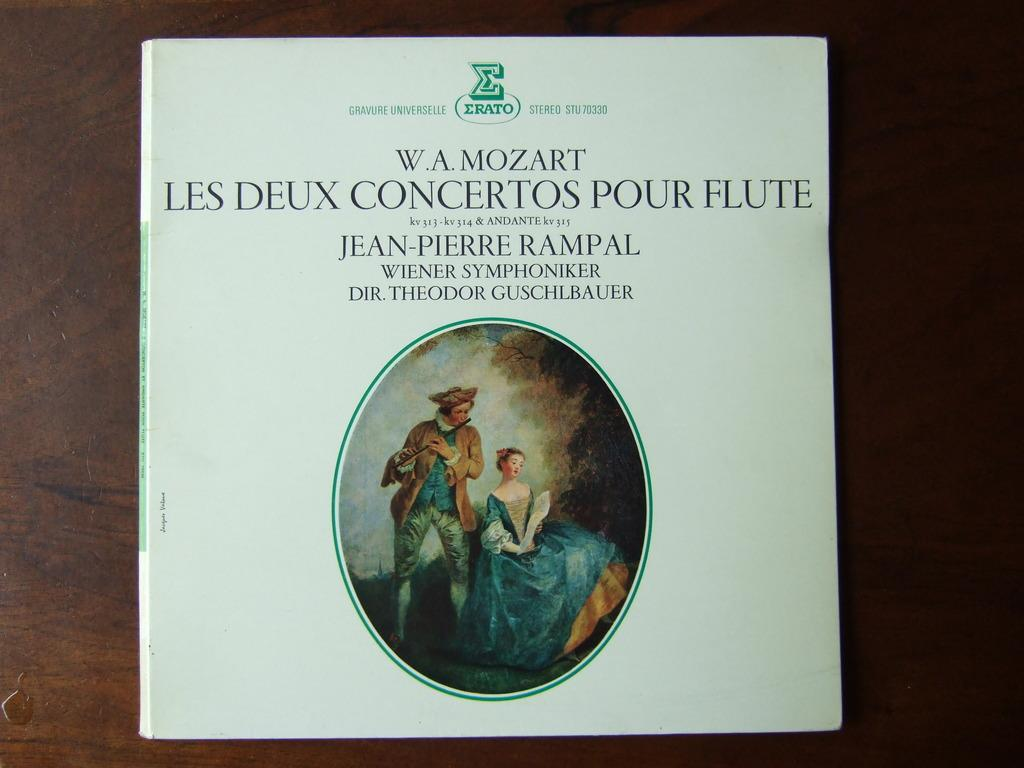What is the main subject of the image? The main subject of the image is the front cover of a book. What can be seen on the front cover? There is an image and text on the front cover. What type of bear is featured on the front cover of the book? There is no bear present on the front cover of the book; it features an image and text related to the book's content. 